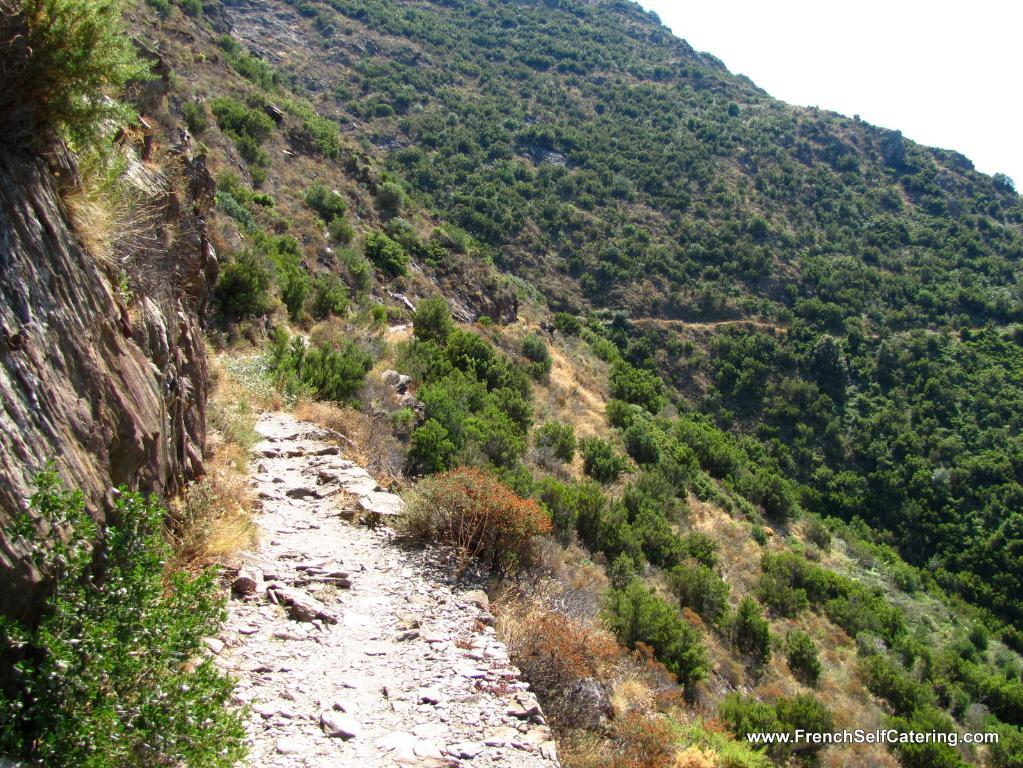Where was the image taken? The image was taken outdoors. What can be seen on the hills in the image? There is grass on the hills in the image. What type of vegetation is present in the image? There are plants and many trees in the image. What type of cushion can be seen on the trees in the image? There are no cushions present on the trees in the image. 